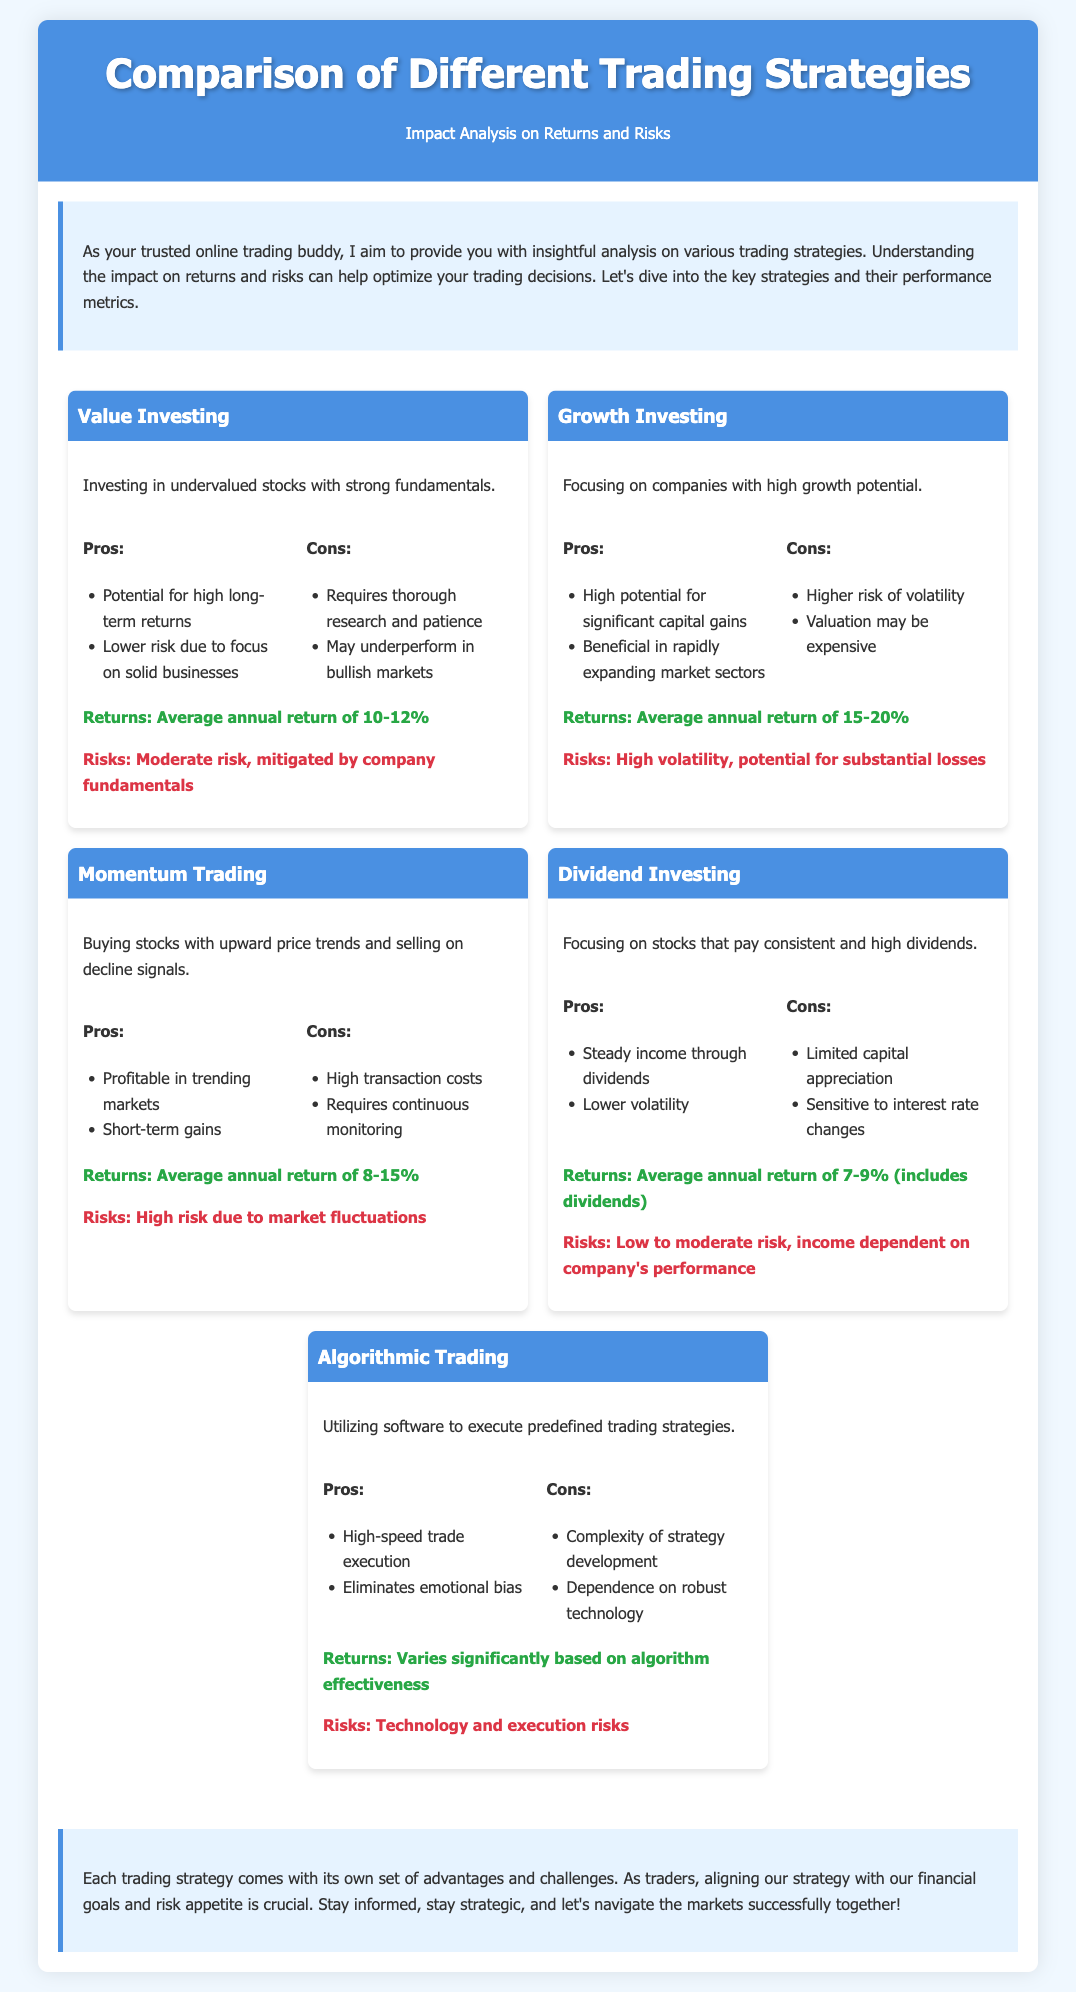What is the average annual return for Value Investing? The average annual return for Value Investing is stated in the document as 10-12%.
Answer: 10-12% What is a major con of Growth Investing? The document lists higher risk of volatility as a significant drawback of Growth Investing.
Answer: Higher risk of volatility What kind of trading does Momentum Trading focus on? The document states Momentum Trading focuses on buying stocks with upward price trends.
Answer: Upward price trends What is the average annual return for Dividend Investing? The average annual return of Dividend Investing is noted in the document including dividends as 7-9%.
Answer: 7-9% Which trading strategy emphasizes eliminating emotional bias? The document mentions Algorithmic Trading as the strategy that eliminates emotional bias.
Answer: Algorithmic Trading What risk category best describes Dividend Investing? The document categorizes Dividend Investing as having low to moderate risk.
Answer: Low to moderate risk What is one advantage of using Algorithmic Trading? The document lists high-speed trade execution as a benefit of Algorithmic Trading.
Answer: High-speed trade execution How does Value Investing mitigate risks? The document states that Value Investing is mitigated by company fundamentals.
Answer: Company fundamentals 